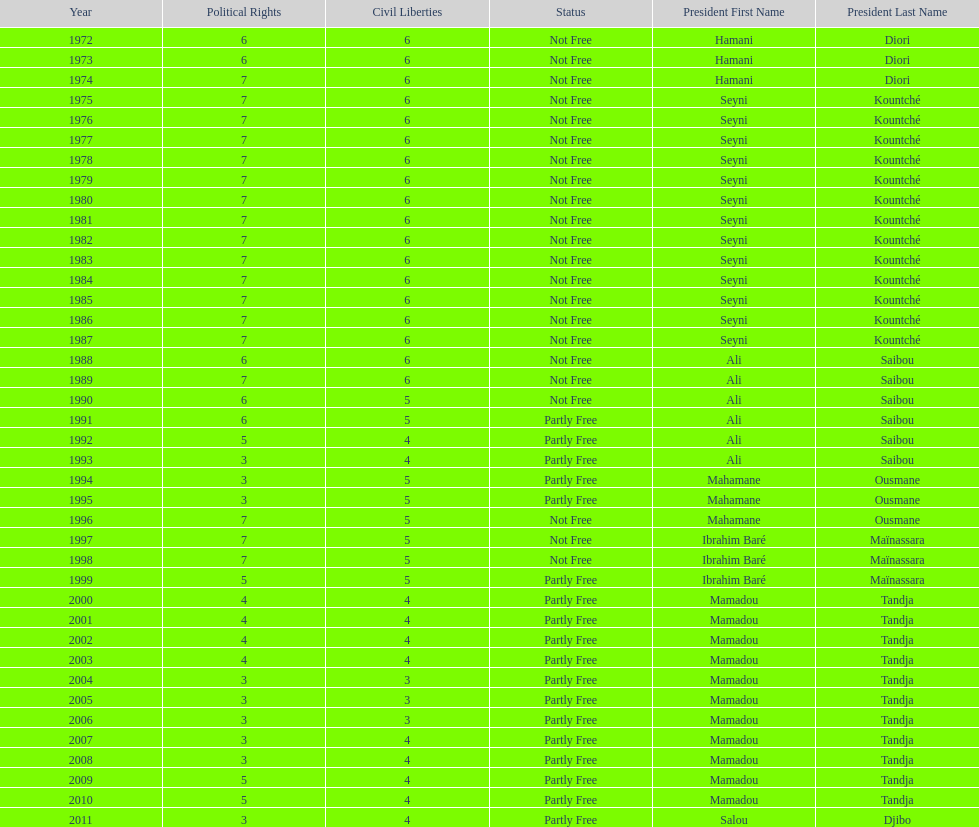How long did it take for civil liberties to decrease below 6? 18 years. 